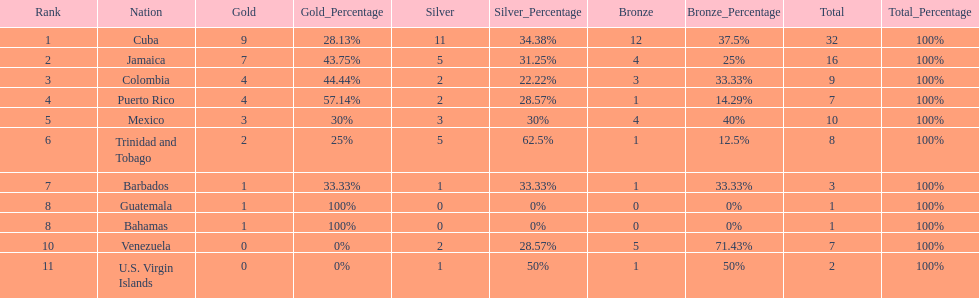Only team to have more than 30 medals Cuba. 